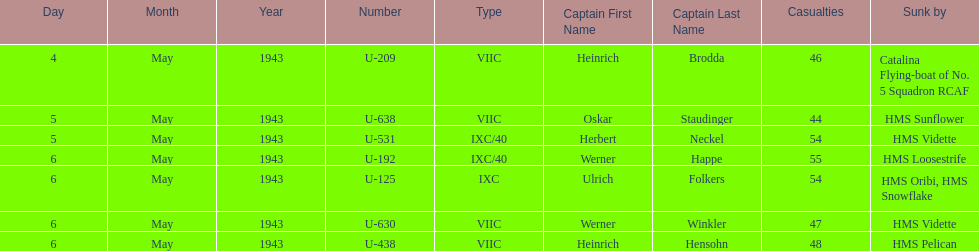Which date had at least 55 casualties? 6 May 1943. 